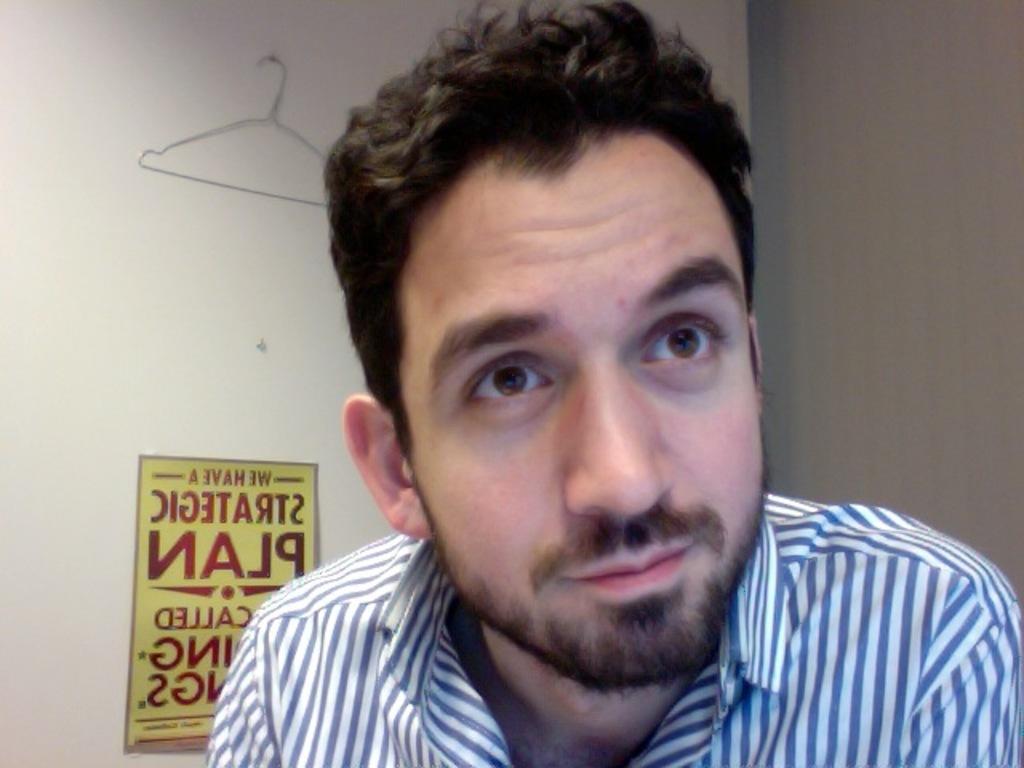Describe this image in one or two sentences. In the picture we can see a man wearing a shirt and with blue and white color lines on it and he is with beard and behind him we can see a door with a hanger to it. 